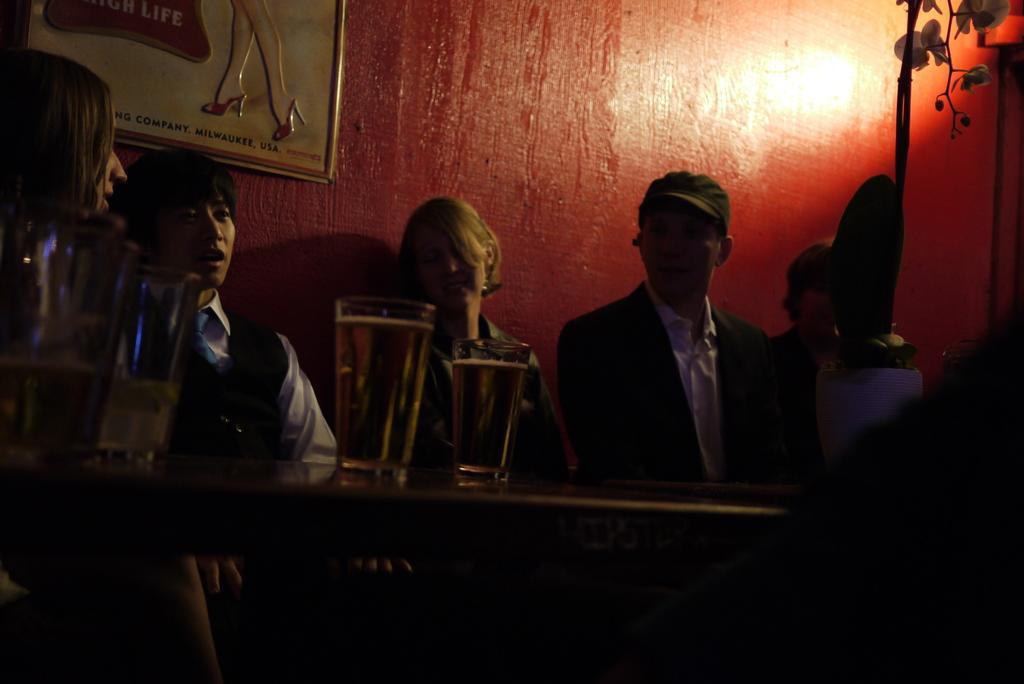Could you give a brief overview of what you see in this image? In this picture there are group of people who are sitting on the chair. There is a glass on the table. There is a frame on the wall. There is a plant. 